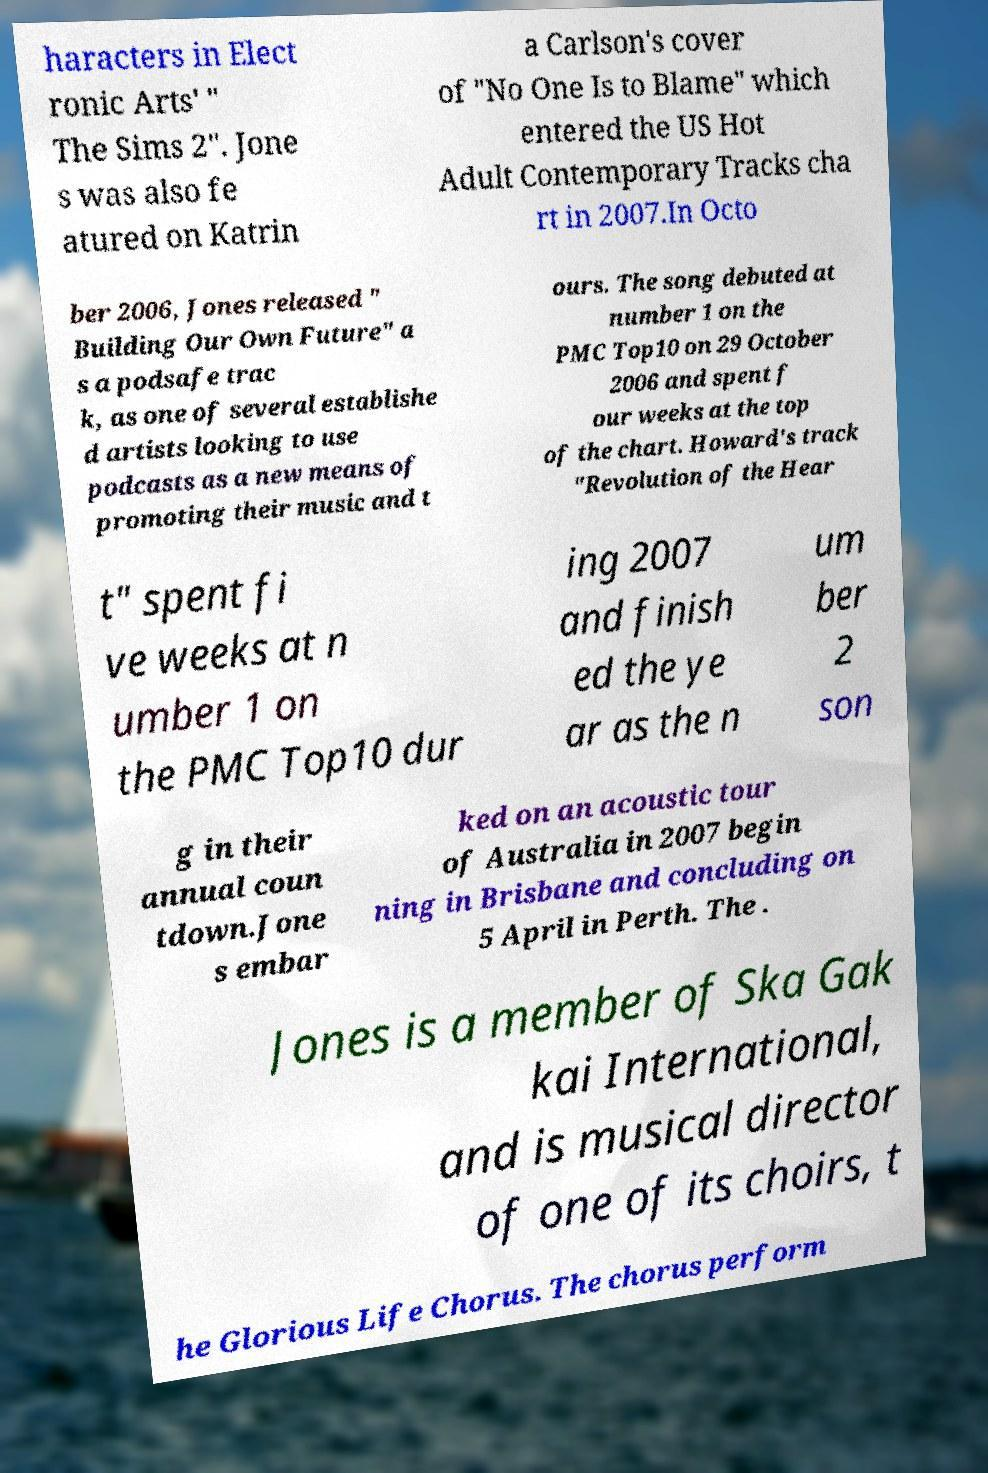Please identify and transcribe the text found in this image. haracters in Elect ronic Arts' " The Sims 2". Jone s was also fe atured on Katrin a Carlson's cover of "No One Is to Blame" which entered the US Hot Adult Contemporary Tracks cha rt in 2007.In Octo ber 2006, Jones released " Building Our Own Future" a s a podsafe trac k, as one of several establishe d artists looking to use podcasts as a new means of promoting their music and t ours. The song debuted at number 1 on the PMC Top10 on 29 October 2006 and spent f our weeks at the top of the chart. Howard's track "Revolution of the Hear t" spent fi ve weeks at n umber 1 on the PMC Top10 dur ing 2007 and finish ed the ye ar as the n um ber 2 son g in their annual coun tdown.Jone s embar ked on an acoustic tour of Australia in 2007 begin ning in Brisbane and concluding on 5 April in Perth. The . Jones is a member of Ska Gak kai International, and is musical director of one of its choirs, t he Glorious Life Chorus. The chorus perform 